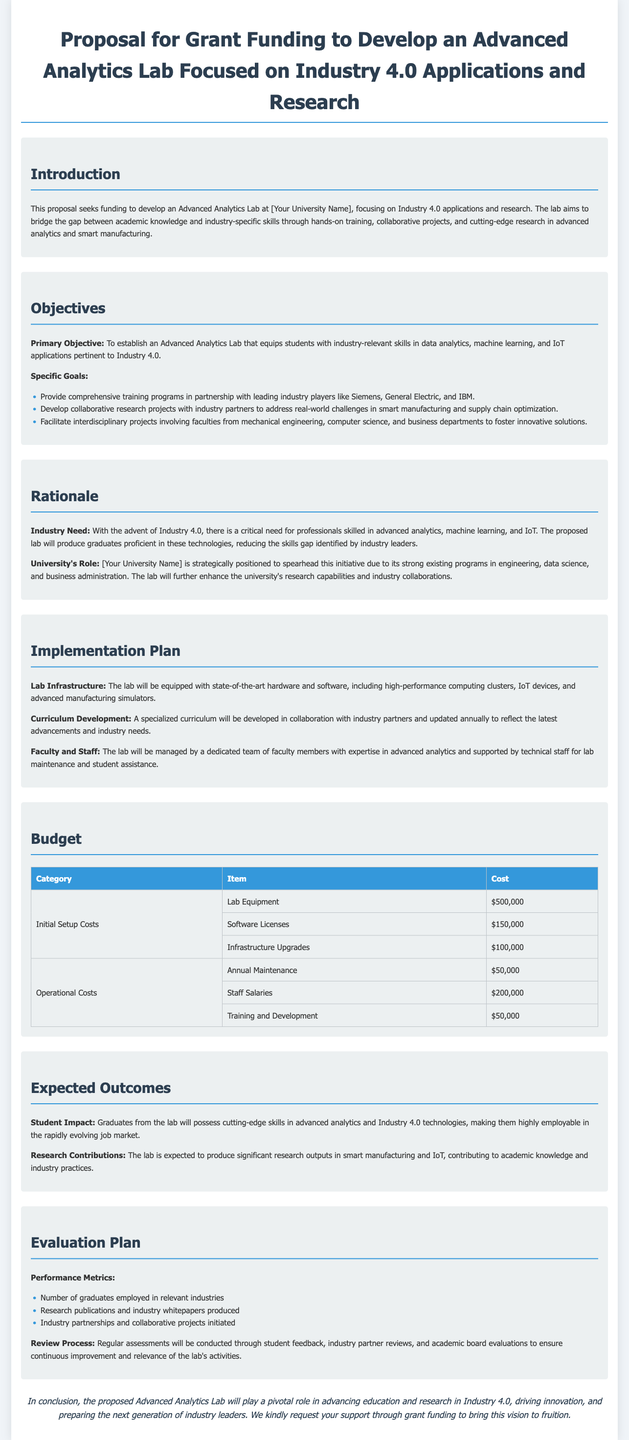what is the primary objective of the proposal? The primary objective is to establish an Advanced Analytics Lab that equips students with industry-relevant skills in data analytics, machine learning, and IoT applications pertinent to Industry 4.0.
Answer: To establish an Advanced Analytics Lab that equips students with industry-relevant skills in data analytics, machine learning, and IoT applications pertinent to Industry 4.0 how much is allocated for lab equipment? The budget allocates a specific amount for lab equipment as part of the initial setup costs.
Answer: $500,000 who are the industry partners mentioned in the proposal? The proposal lists industry partners that are involved in the training programs.
Answer: Siemens, General Electric, and IBM what is the annual maintenance cost listed in the budget? The document provides details on the annual maintenance costs associated with the lab.
Answer: $50,000 what types of projects will the lab facilitate? The proposal mentions specific types of projects that the lab will encourage, focusing on industry collaboration.
Answer: Interdisciplinary projects involving faculties from mechanical engineering, computer science, and business departments how will the lab be evaluated? The evaluation plan includes specific metrics for assessing the lab's performance and effectiveness.
Answer: Regular assessments through student feedback, industry partner reviews, and academic board evaluations what is the expected impact on graduates? The section on expected outcomes describes the skills graduates will gain from the program.
Answer: Possess cutting-edge skills in advanced analytics and Industry 4.0 technologies what type of curriculum will the lab have? The proposal indicates the nature of the curriculum that will be developed for the lab.
Answer: A specialized curriculum developed in collaboration with industry partners 